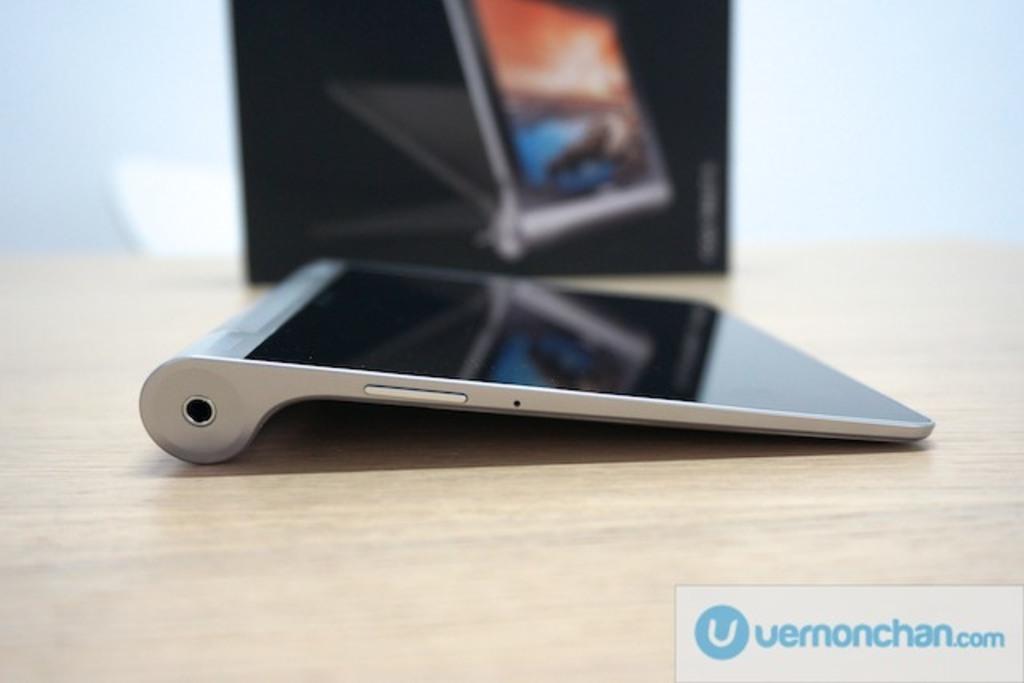Is there a website to visit?
Provide a short and direct response. Yes. What website is mentioned?
Make the answer very short. Uernonchan.com. 